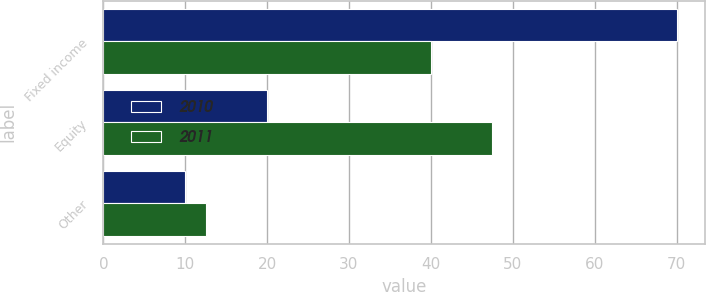Convert chart to OTSL. <chart><loc_0><loc_0><loc_500><loc_500><stacked_bar_chart><ecel><fcel>Fixed income<fcel>Equity<fcel>Other<nl><fcel>2010<fcel>70<fcel>20<fcel>10<nl><fcel>2011<fcel>40<fcel>47.5<fcel>12.5<nl></chart> 